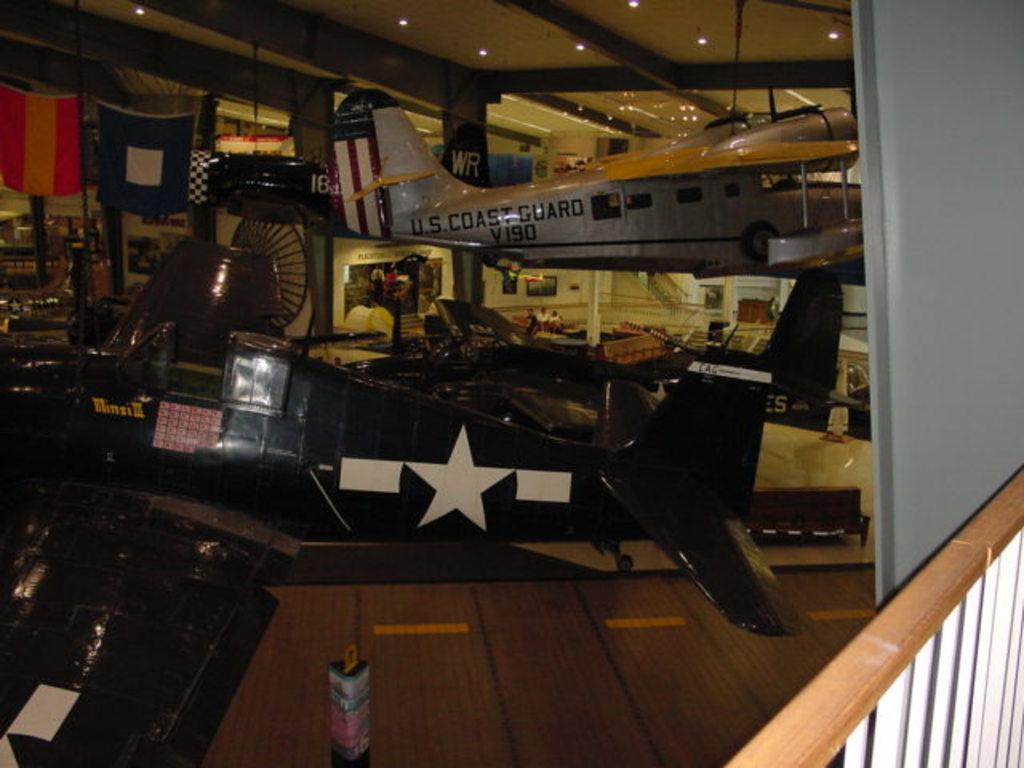Could you give a brief overview of what you see in this image? In this image in the center there are some airplanes, flags and some other objects. At the bottom there is a wooden floor and one box, in the background there is a wall, pillars and some photo frames on the wall. On the top there is ceiling and lights and there are some wooden poles. 